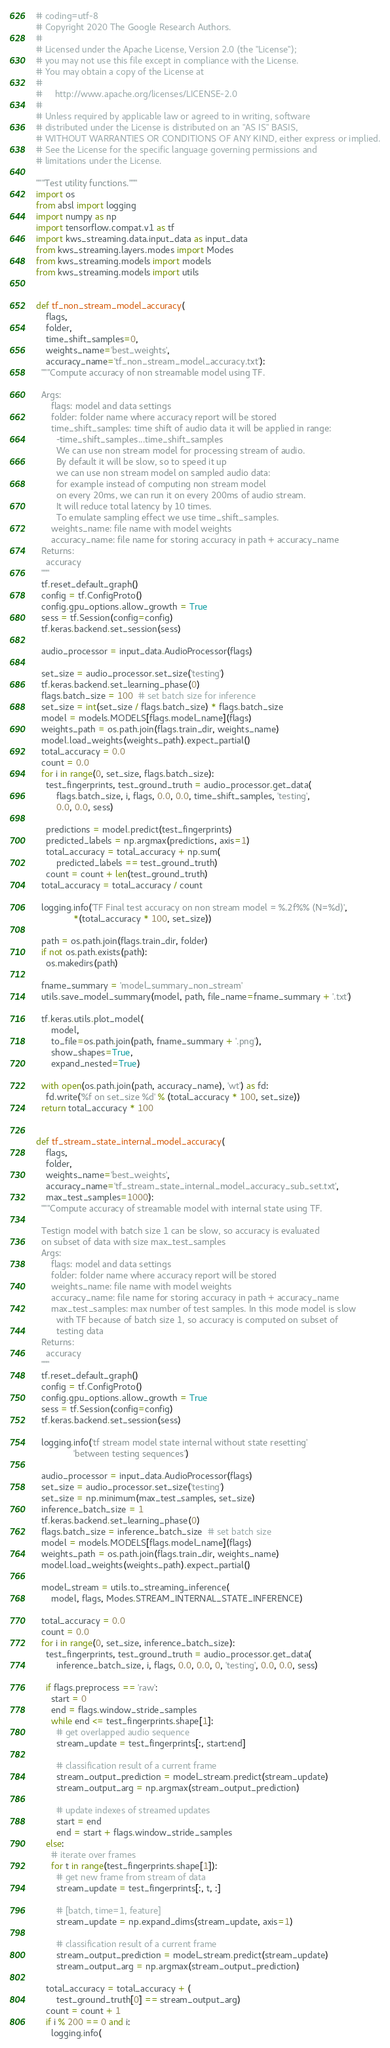<code> <loc_0><loc_0><loc_500><loc_500><_Python_># coding=utf-8
# Copyright 2020 The Google Research Authors.
#
# Licensed under the Apache License, Version 2.0 (the "License");
# you may not use this file except in compliance with the License.
# You may obtain a copy of the License at
#
#     http://www.apache.org/licenses/LICENSE-2.0
#
# Unless required by applicable law or agreed to in writing, software
# distributed under the License is distributed on an "AS IS" BASIS,
# WITHOUT WARRANTIES OR CONDITIONS OF ANY KIND, either express or implied.
# See the License for the specific language governing permissions and
# limitations under the License.

"""Test utility functions."""
import os
from absl import logging
import numpy as np
import tensorflow.compat.v1 as tf
import kws_streaming.data.input_data as input_data
from kws_streaming.layers.modes import Modes
from kws_streaming.models import models
from kws_streaming.models import utils


def tf_non_stream_model_accuracy(
    flags,
    folder,
    time_shift_samples=0,
    weights_name='best_weights',
    accuracy_name='tf_non_stream_model_accuracy.txt'):
  """Compute accuracy of non streamable model using TF.

  Args:
      flags: model and data settings
      folder: folder name where accuracy report will be stored
      time_shift_samples: time shift of audio data it will be applied in range:
        -time_shift_samples...time_shift_samples
        We can use non stream model for processing stream of audio.
        By default it will be slow, so to speed it up
        we can use non stream model on sampled audio data:
        for example instead of computing non stream model
        on every 20ms, we can run it on every 200ms of audio stream.
        It will reduce total latency by 10 times.
        To emulate sampling effect we use time_shift_samples.
      weights_name: file name with model weights
      accuracy_name: file name for storing accuracy in path + accuracy_name
  Returns:
    accuracy
  """
  tf.reset_default_graph()
  config = tf.ConfigProto()
  config.gpu_options.allow_growth = True
  sess = tf.Session(config=config)
  tf.keras.backend.set_session(sess)

  audio_processor = input_data.AudioProcessor(flags)

  set_size = audio_processor.set_size('testing')
  tf.keras.backend.set_learning_phase(0)
  flags.batch_size = 100  # set batch size for inference
  set_size = int(set_size / flags.batch_size) * flags.batch_size
  model = models.MODELS[flags.model_name](flags)
  weights_path = os.path.join(flags.train_dir, weights_name)
  model.load_weights(weights_path).expect_partial()
  total_accuracy = 0.0
  count = 0.0
  for i in range(0, set_size, flags.batch_size):
    test_fingerprints, test_ground_truth = audio_processor.get_data(
        flags.batch_size, i, flags, 0.0, 0.0, time_shift_samples, 'testing',
        0.0, 0.0, sess)

    predictions = model.predict(test_fingerprints)
    predicted_labels = np.argmax(predictions, axis=1)
    total_accuracy = total_accuracy + np.sum(
        predicted_labels == test_ground_truth)
    count = count + len(test_ground_truth)
  total_accuracy = total_accuracy / count

  logging.info('TF Final test accuracy on non stream model = %.2f%% (N=%d)',
               *(total_accuracy * 100, set_size))

  path = os.path.join(flags.train_dir, folder)
  if not os.path.exists(path):
    os.makedirs(path)

  fname_summary = 'model_summary_non_stream'
  utils.save_model_summary(model, path, file_name=fname_summary + '.txt')

  tf.keras.utils.plot_model(
      model,
      to_file=os.path.join(path, fname_summary + '.png'),
      show_shapes=True,
      expand_nested=True)

  with open(os.path.join(path, accuracy_name), 'wt') as fd:
    fd.write('%f on set_size %d' % (total_accuracy * 100, set_size))
  return total_accuracy * 100


def tf_stream_state_internal_model_accuracy(
    flags,
    folder,
    weights_name='best_weights',
    accuracy_name='tf_stream_state_internal_model_accuracy_sub_set.txt',
    max_test_samples=1000):
  """Compute accuracy of streamable model with internal state using TF.

  Testign model with batch size 1 can be slow, so accuracy is evaluated
  on subset of data with size max_test_samples
  Args:
      flags: model and data settings
      folder: folder name where accuracy report will be stored
      weights_name: file name with model weights
      accuracy_name: file name for storing accuracy in path + accuracy_name
      max_test_samples: max number of test samples. In this mode model is slow
        with TF because of batch size 1, so accuracy is computed on subset of
        testing data
  Returns:
    accuracy
  """
  tf.reset_default_graph()
  config = tf.ConfigProto()
  config.gpu_options.allow_growth = True
  sess = tf.Session(config=config)
  tf.keras.backend.set_session(sess)

  logging.info('tf stream model state internal without state resetting'
               'between testing sequences')

  audio_processor = input_data.AudioProcessor(flags)
  set_size = audio_processor.set_size('testing')
  set_size = np.minimum(max_test_samples, set_size)
  inference_batch_size = 1
  tf.keras.backend.set_learning_phase(0)
  flags.batch_size = inference_batch_size  # set batch size
  model = models.MODELS[flags.model_name](flags)
  weights_path = os.path.join(flags.train_dir, weights_name)
  model.load_weights(weights_path).expect_partial()

  model_stream = utils.to_streaming_inference(
      model, flags, Modes.STREAM_INTERNAL_STATE_INFERENCE)

  total_accuracy = 0.0
  count = 0.0
  for i in range(0, set_size, inference_batch_size):
    test_fingerprints, test_ground_truth = audio_processor.get_data(
        inference_batch_size, i, flags, 0.0, 0.0, 0, 'testing', 0.0, 0.0, sess)

    if flags.preprocess == 'raw':
      start = 0
      end = flags.window_stride_samples
      while end <= test_fingerprints.shape[1]:
        # get overlapped audio sequence
        stream_update = test_fingerprints[:, start:end]

        # classification result of a current frame
        stream_output_prediction = model_stream.predict(stream_update)
        stream_output_arg = np.argmax(stream_output_prediction)

        # update indexes of streamed updates
        start = end
        end = start + flags.window_stride_samples
    else:
      # iterate over frames
      for t in range(test_fingerprints.shape[1]):
        # get new frame from stream of data
        stream_update = test_fingerprints[:, t, :]

        # [batch, time=1, feature]
        stream_update = np.expand_dims(stream_update, axis=1)

        # classification result of a current frame
        stream_output_prediction = model_stream.predict(stream_update)
        stream_output_arg = np.argmax(stream_output_prediction)

    total_accuracy = total_accuracy + (
        test_ground_truth[0] == stream_output_arg)
    count = count + 1
    if i % 200 == 0 and i:
      logging.info(</code> 